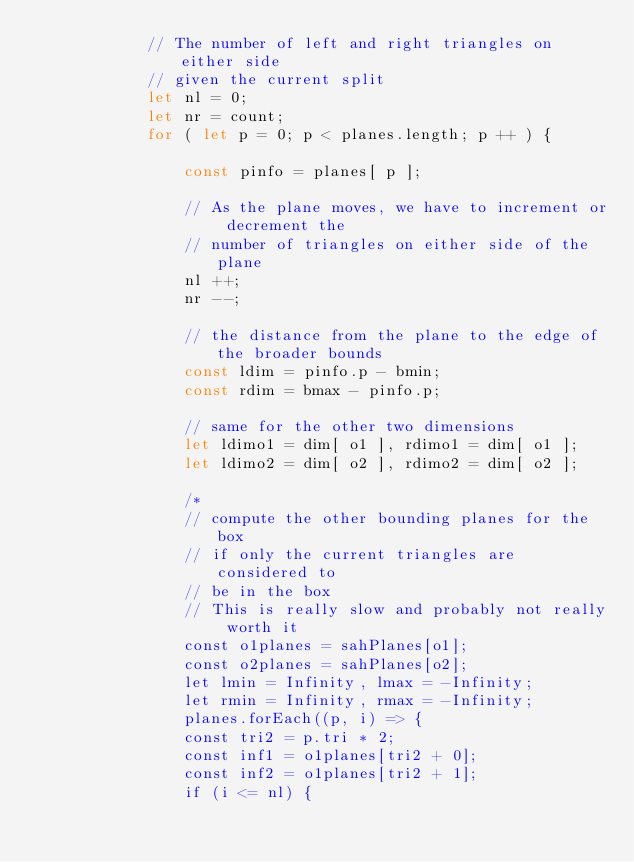<code> <loc_0><loc_0><loc_500><loc_500><_JavaScript_>			// The number of left and right triangles on either side
			// given the current split
			let nl = 0;
			let nr = count;
			for ( let p = 0; p < planes.length; p ++ ) {

				const pinfo = planes[ p ];

				// As the plane moves, we have to increment or decrement the
				// number of triangles on either side of the plane
				nl ++;
				nr --;

				// the distance from the plane to the edge of the broader bounds
				const ldim = pinfo.p - bmin;
				const rdim = bmax - pinfo.p;

				// same for the other two dimensions
				let ldimo1 = dim[ o1 ], rdimo1 = dim[ o1 ];
				let ldimo2 = dim[ o2 ], rdimo2 = dim[ o2 ];

				/*
				// compute the other bounding planes for the box
				// if only the current triangles are considered to
				// be in the box
				// This is really slow and probably not really worth it
				const o1planes = sahPlanes[o1];
				const o2planes = sahPlanes[o2];
				let lmin = Infinity, lmax = -Infinity;
				let rmin = Infinity, rmax = -Infinity;
				planes.forEach((p, i) => {
				const tri2 = p.tri * 2;
				const inf1 = o1planes[tri2 + 0];
				const inf2 = o1planes[tri2 + 1];
				if (i <= nl) {</code> 